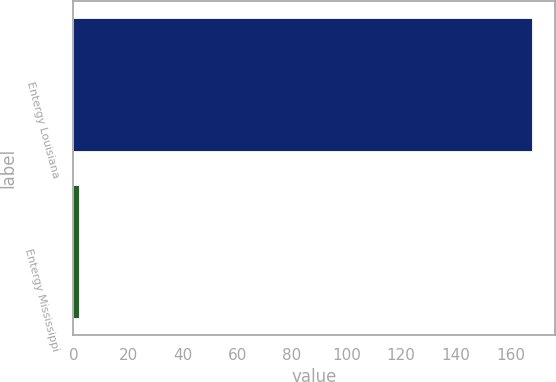Convert chart to OTSL. <chart><loc_0><loc_0><loc_500><loc_500><bar_chart><fcel>Entergy Louisiana<fcel>Entergy Mississippi<nl><fcel>168<fcel>2<nl></chart> 